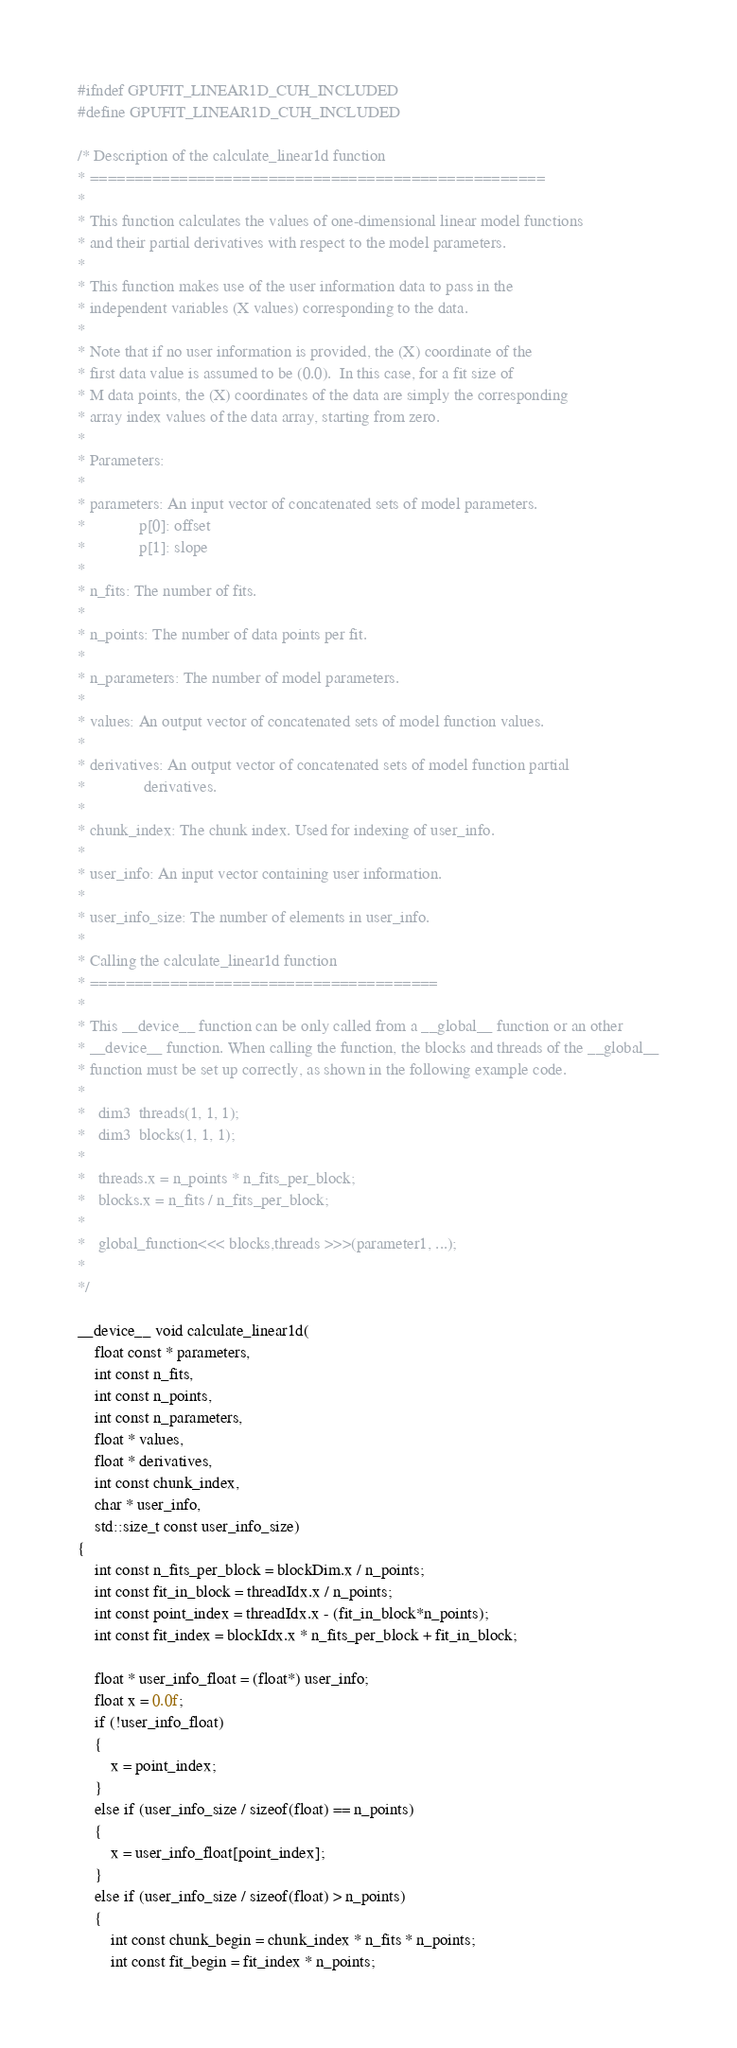<code> <loc_0><loc_0><loc_500><loc_500><_Cuda_>#ifndef GPUFIT_LINEAR1D_CUH_INCLUDED
#define GPUFIT_LINEAR1D_CUH_INCLUDED

/* Description of the calculate_linear1d function
* ===================================================
*
* This function calculates the values of one-dimensional linear model functions
* and their partial derivatives with respect to the model parameters. 
*
* This function makes use of the user information data to pass in the 
* independent variables (X values) corresponding to the data.  
*
* Note that if no user information is provided, the (X) coordinate of the 
* first data value is assumed to be (0.0).  In this case, for a fit size of 
* M data points, the (X) coordinates of the data are simply the corresponding 
* array index values of the data array, starting from zero.
*
* Parameters:
*
* parameters: An input vector of concatenated sets of model parameters.
*             p[0]: offset
*             p[1]: slope
*
* n_fits: The number of fits.
*
* n_points: The number of data points per fit.
*
* n_parameters: The number of model parameters.
*
* values: An output vector of concatenated sets of model function values.
*
* derivatives: An output vector of concatenated sets of model function partial
*              derivatives.
*
* chunk_index: The chunk index. Used for indexing of user_info.
*
* user_info: An input vector containing user information.
*
* user_info_size: The number of elements in user_info.
*
* Calling the calculate_linear1d function
* =======================================
*
* This __device__ function can be only called from a __global__ function or an other
* __device__ function. When calling the function, the blocks and threads of the __global__
* function must be set up correctly, as shown in the following example code.
*
*   dim3  threads(1, 1, 1);
*   dim3  blocks(1, 1, 1);
*
*   threads.x = n_points * n_fits_per_block;
*   blocks.x = n_fits / n_fits_per_block;
*
*   global_function<<< blocks,threads >>>(parameter1, ...);
*
*/

__device__ void calculate_linear1d(
    float const * parameters,
    int const n_fits,
    int const n_points,
    int const n_parameters,
    float * values,
    float * derivatives,
    int const chunk_index,
    char * user_info,
    std::size_t const user_info_size)
{
    int const n_fits_per_block = blockDim.x / n_points;
    int const fit_in_block = threadIdx.x / n_points;
    int const point_index = threadIdx.x - (fit_in_block*n_points);
    int const fit_index = blockIdx.x * n_fits_per_block + fit_in_block;

    float * user_info_float = (float*) user_info;
    float x = 0.0f;
    if (!user_info_float)
    {
        x = point_index;
    }
    else if (user_info_size / sizeof(float) == n_points)
    {
        x = user_info_float[point_index];
    }
    else if (user_info_size / sizeof(float) > n_points)
    {
        int const chunk_begin = chunk_index * n_fits * n_points;
        int const fit_begin = fit_index * n_points;</code> 